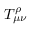<formula> <loc_0><loc_0><loc_500><loc_500>T _ { \mu \nu } ^ { \rho }</formula> 